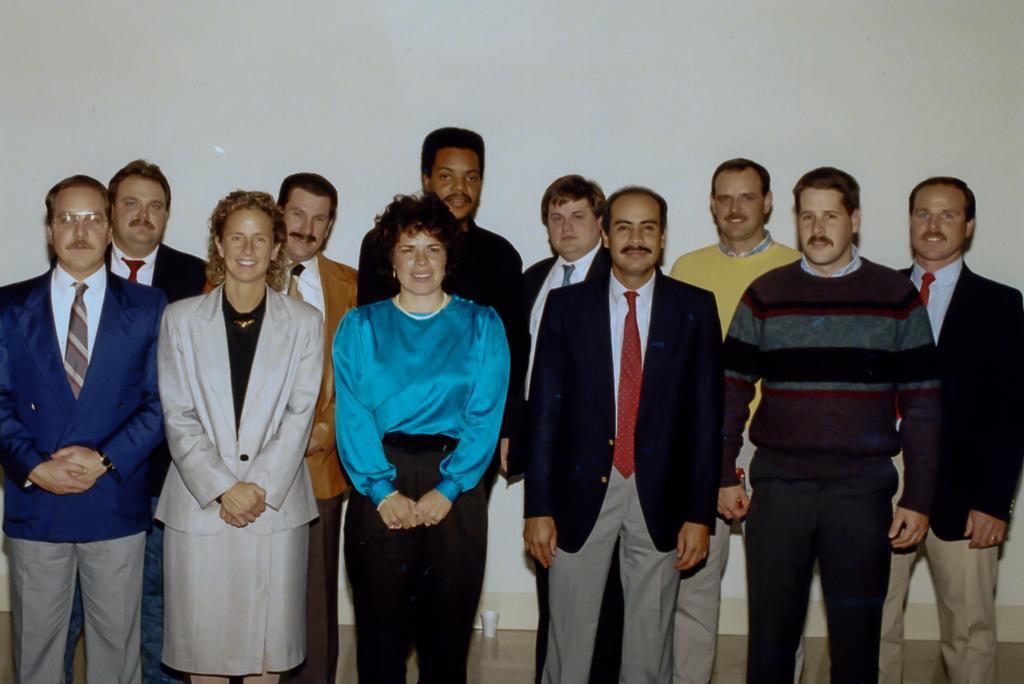How would you summarize this image in a sentence or two? In the picture I can see a group of people standing on the floor and they are smiling. In the picture I can see a few men wearing a suit and tie. There is a man on the right side is wearing the sweater. In the background, I can see the wall. I can see a cup on the floor at the bottom of the picture. 